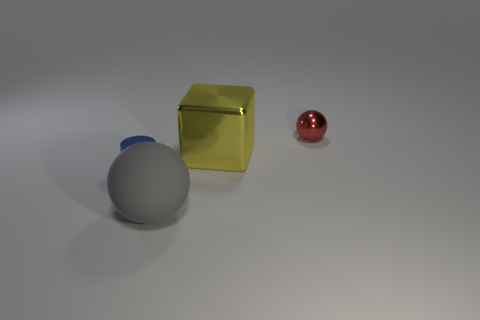Can you tell me what shapes are visible in the image and their arrangement? Certainly! In the image, there are three shapes: a large blue hemisphere with its flat side on the surface, a yellow cube, and a small red sphere. The hemisphere is in the foreground, the cube is placed to its right and a bit behind it, and the small sphere is further to the right and slightly behind the cube. 